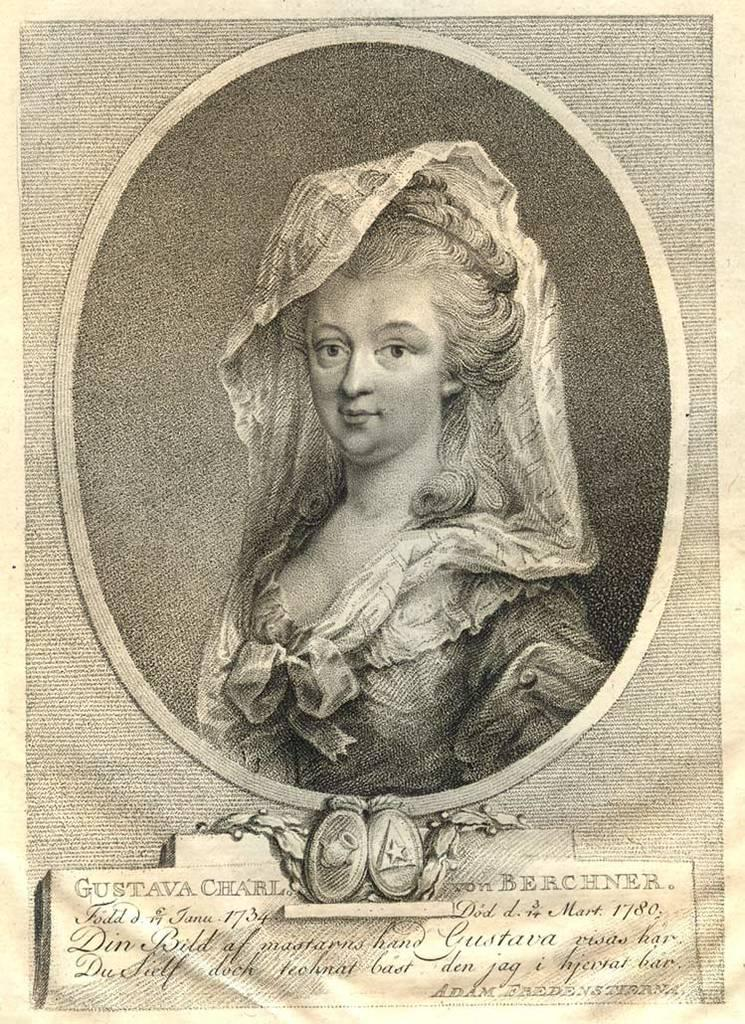What is the main object in the image? There is a paper in the image. What is depicted on the paper? A person with a dress is depicted on the paper. What else can be seen on the paper? Text is written on the paper. What colors are used in the paper's design? The paper has a black and cream color scheme. What type of leaf is being used as a plate for the breakfast in the image? There is no leaf or breakfast present in the image; it features a paper with a person and text. Which type of berry is being used as a decoration on the person's dress in the image? There are no berries depicted on the person's dress in the image. 